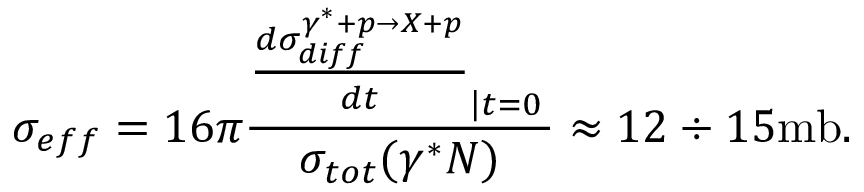Convert formula to latex. <formula><loc_0><loc_0><loc_500><loc_500>\sigma _ { e f f } = 1 6 \pi { \frac { { \frac { d \sigma _ { d i f f } ^ { \gamma ^ { * } + p \rightarrow X + p } } { d t } } _ { \left | t = 0 } } { \sigma _ { t o t } ( \gamma ^ { * } N ) } } \approx 1 2 \div 1 5 m b .</formula> 